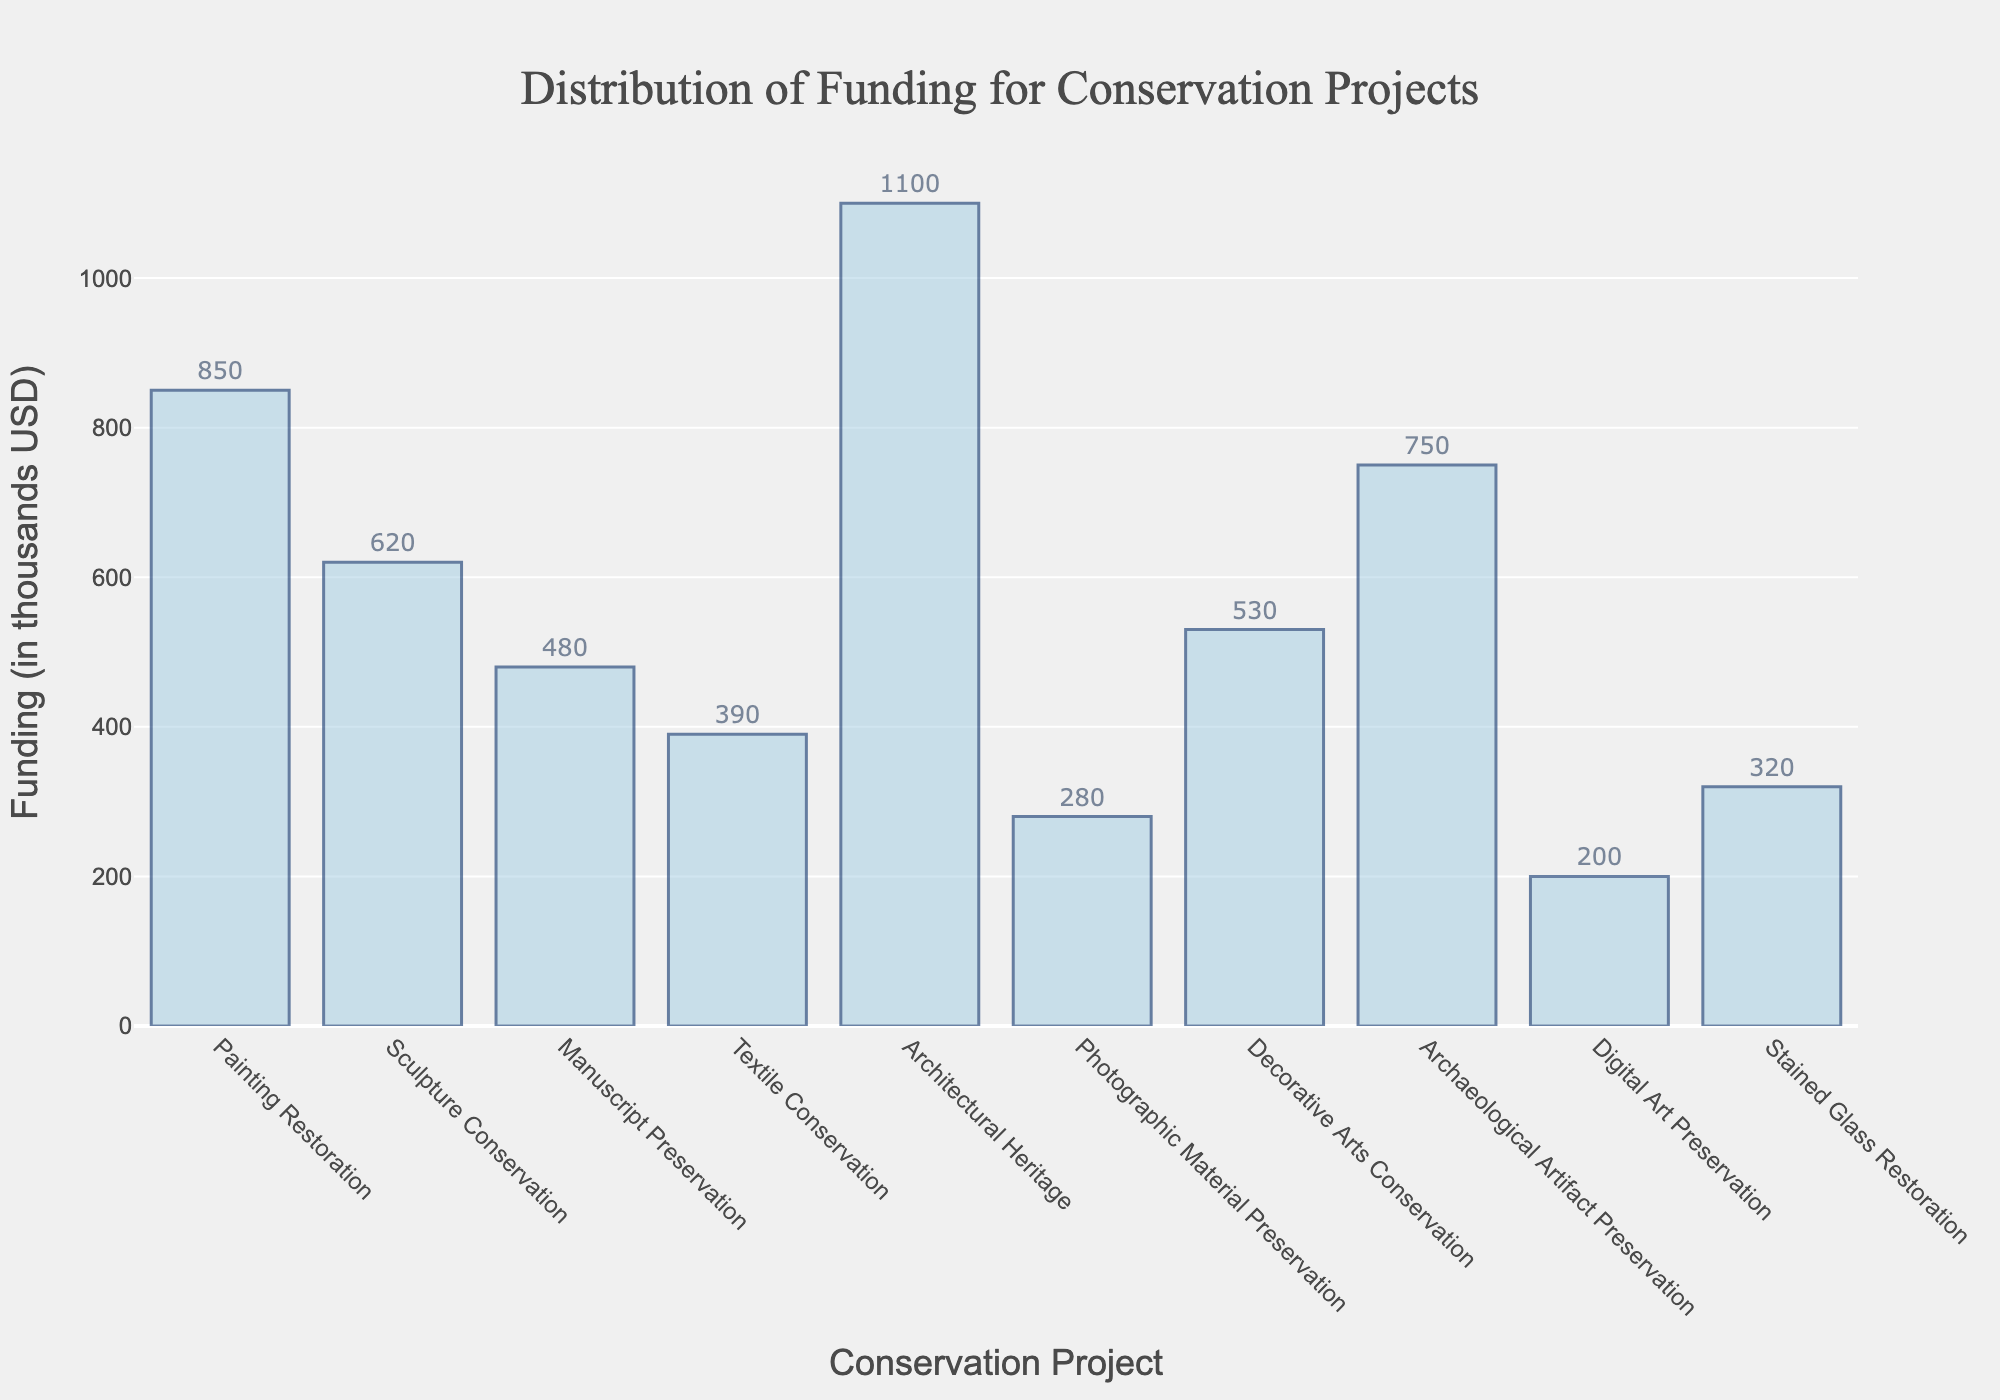What's the title of the graph? The title of the graph is usually at the top and indicates what the graph represents. Here, it's written prominently.
Answer: Distribution of Funding for Conservation Projects How many conservation projects are listed in the histogram? Count the number of bars in the histogram, each representing a project.
Answer: 10 Which conservation project received the highest funding? Find the tallest bar in the histogram which represents the highest funding amount.
Answer: Architectural Heritage What is the funding amount for Digital Art Preservation? Look for the bar labeled "Digital Art Preservation" and note its height on the y-axis.
Answer: 200 thousand USD What is the total funding allocated for Sculpture Conservation and Textile Conservation? Identify the bars for Sculpture Conservation and Textile Conservation, then add their funding amounts (620 + 390).
Answer: 1010 thousand USD Which project received less funding: Photographic Material Preservation or Stained Glass Restoration? Compare the heights of the bars labeled Photographic Material Preservation and Stained Glass Restoration.
Answer: Photographic Material Preservation How does the funding for Manuscript Preservation compare to Decorative Arts Conservation? Compare the height of the bars for Manuscript Preservation and Decorative Arts Conservation.
Answer: Manuscript Preservation has less funding Which project is midway in terms of funding between Textile Conservation and Archaeological Artifact Preservation? Identify the funding amounts for Textile Conservation (390) and Archaeological Artifact Preservation (750), then find the project with funding between these two.
Answer: Stained Glass Restoration What is the average funding for all projects? Sum all the funding amounts and divide by the number of projects. (850 + 620 + 480 + 390 + 1100 + 280 + 530 + 750 + 200 + 320) / 10 = 5520 / 10.
Answer: 552 thousand USD What's the difference in funding between Painting Restoration and Manuscript Preservation? Subtract the funding amount for Manuscript Preservation from Painting Restoration (850 - 480).
Answer: 370 thousand USD 